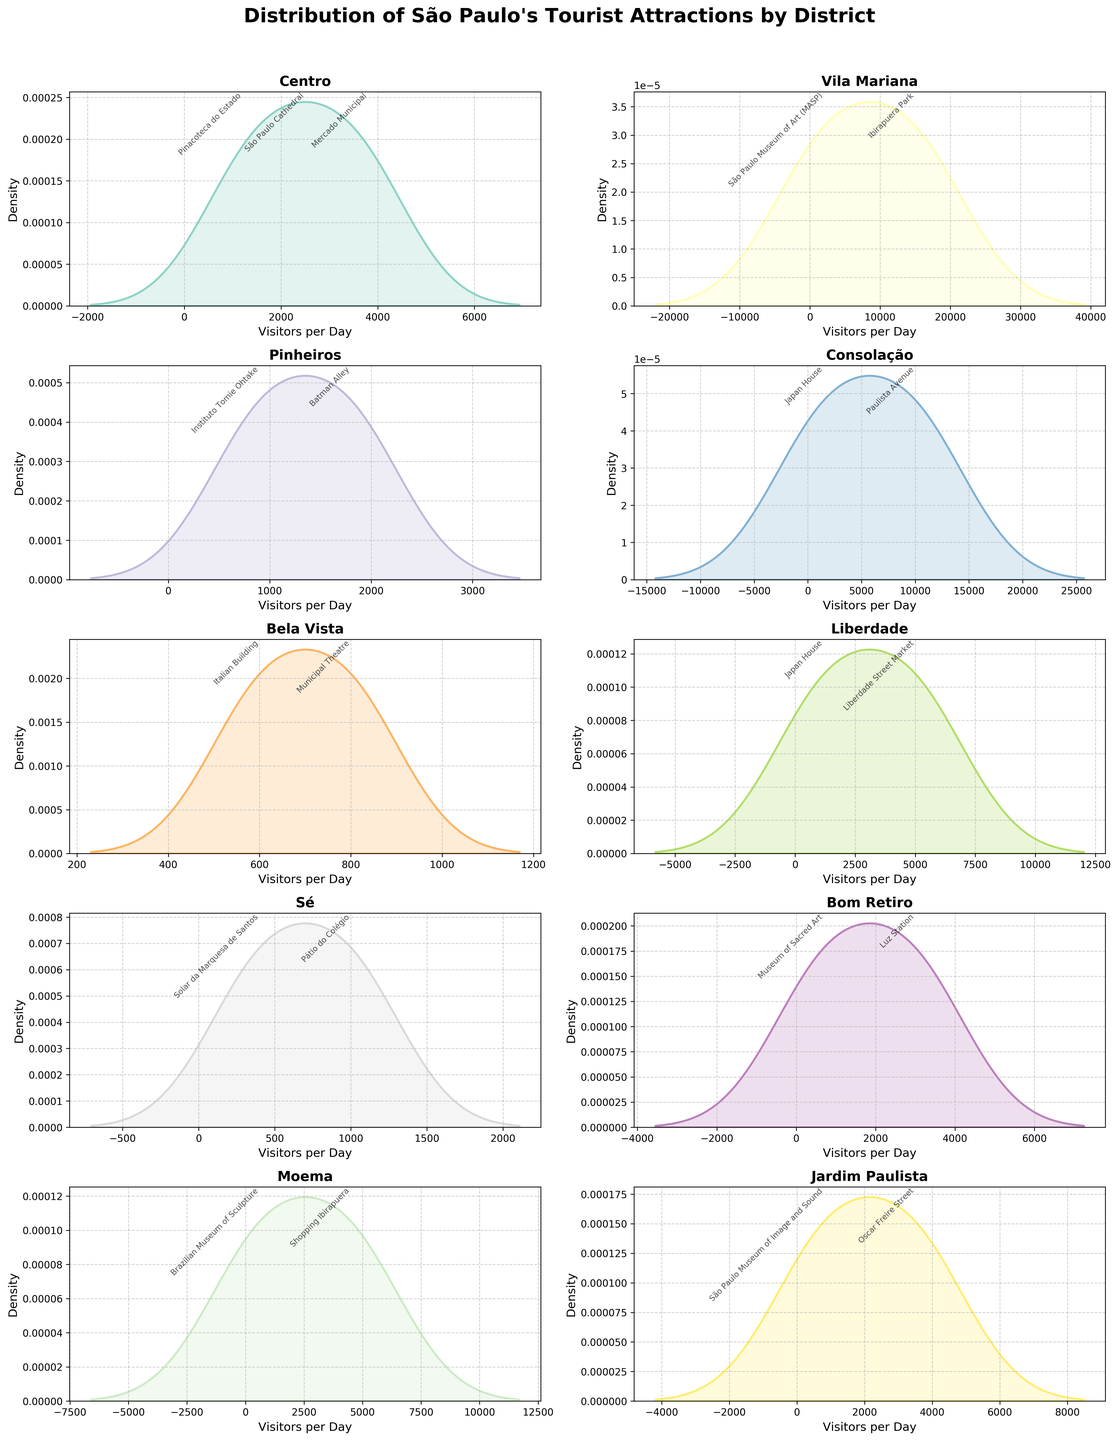What is the title of the chart? The title of the chart is located at the top and is usually in larger or bold font. It reads "Distribution of São Paulo's Tourist Attractions by District".
Answer: Distribution of São Paulo's Tourist Attractions by District Which district has the highest peak in the density plot for visitors per day? By examining the plots, we focus on the peak of each density curve. The district with the highest peak will have the tallest density curve.
Answer: Vila Mariana What is the range of visitors per day for attractions in the Centro district? Look at the x-axis for the Centro district's subplot to identify the minimum and maximum values of the density plot.
Answer: 1200 to 3800 How does the density of visitors per day in Liberdade compare with those in Consolação? Compare the density curves in their respective subplots. The Liberdade district has a prominent peak around 5000 visitors, while Consolação has a large peak around 10000 visitors per day.
Answer: Liberdade has fewer visitors than Consolação Which tourist attraction in Jardim Paulista has the highest average number of visitors per day? In the Jardim Paulista subplot, refer to the text annotations. Identify which attraction has the highest average number associated with it.
Answer: Oscar Freire Street What do the different color shadings in the plots represent? Each subplot's density plot uses a different color to distinguish between districts. The colors do not represent additional data but only differentiate the districts visually.
Answer: Districts Are there any districts with a similar distribution of visitors per day? Compare the shapes of the density plots between different districts. If the curves are similar in shape and range, their distributions are considered similar.
Answer: Bom Retiro and Sé Can you name one attraction with fewer than 1000 visitors per day? Look at the text annotations near lower x-axis values of different subplots. Find an attraction with a value under 1000.
Answer: Italian Building 